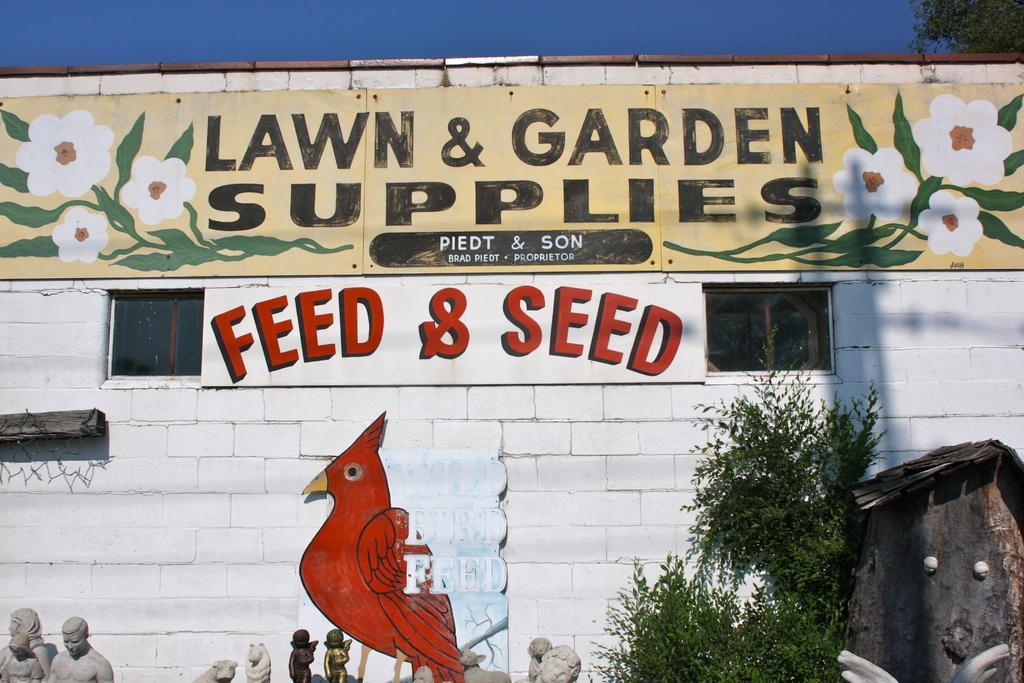How would you summarize this image in a sentence or two? In this picture we can see a painting on the wall. We can see a few windows on the wall. There are few sculptures. Sky is blue in color. We can see some plants on the right side. 